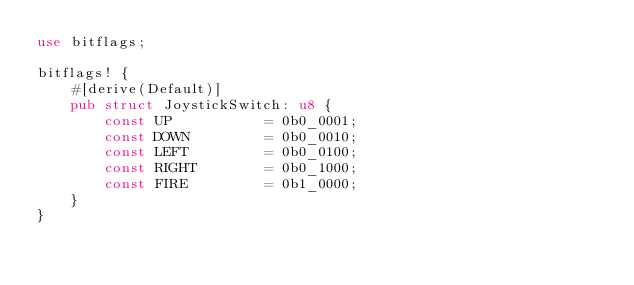<code> <loc_0><loc_0><loc_500><loc_500><_Rust_>use bitflags;

bitflags! {
    #[derive(Default)]
    pub struct JoystickSwitch: u8 {
        const UP           = 0b0_0001;
        const DOWN         = 0b0_0010;
        const LEFT         = 0b0_0100;
        const RIGHT        = 0b0_1000;
        const FIRE         = 0b1_0000;
    }
}
</code> 